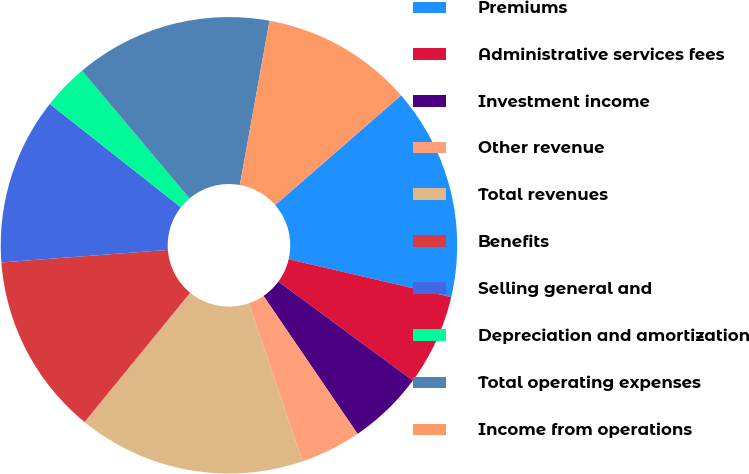<chart> <loc_0><loc_0><loc_500><loc_500><pie_chart><fcel>Premiums<fcel>Administrative services fees<fcel>Investment income<fcel>Other revenue<fcel>Total revenues<fcel>Benefits<fcel>Selling general and<fcel>Depreciation and amortization<fcel>Total operating expenses<fcel>Income from operations<nl><fcel>15.05%<fcel>6.45%<fcel>5.38%<fcel>4.3%<fcel>16.13%<fcel>12.9%<fcel>11.83%<fcel>3.23%<fcel>13.98%<fcel>10.75%<nl></chart> 